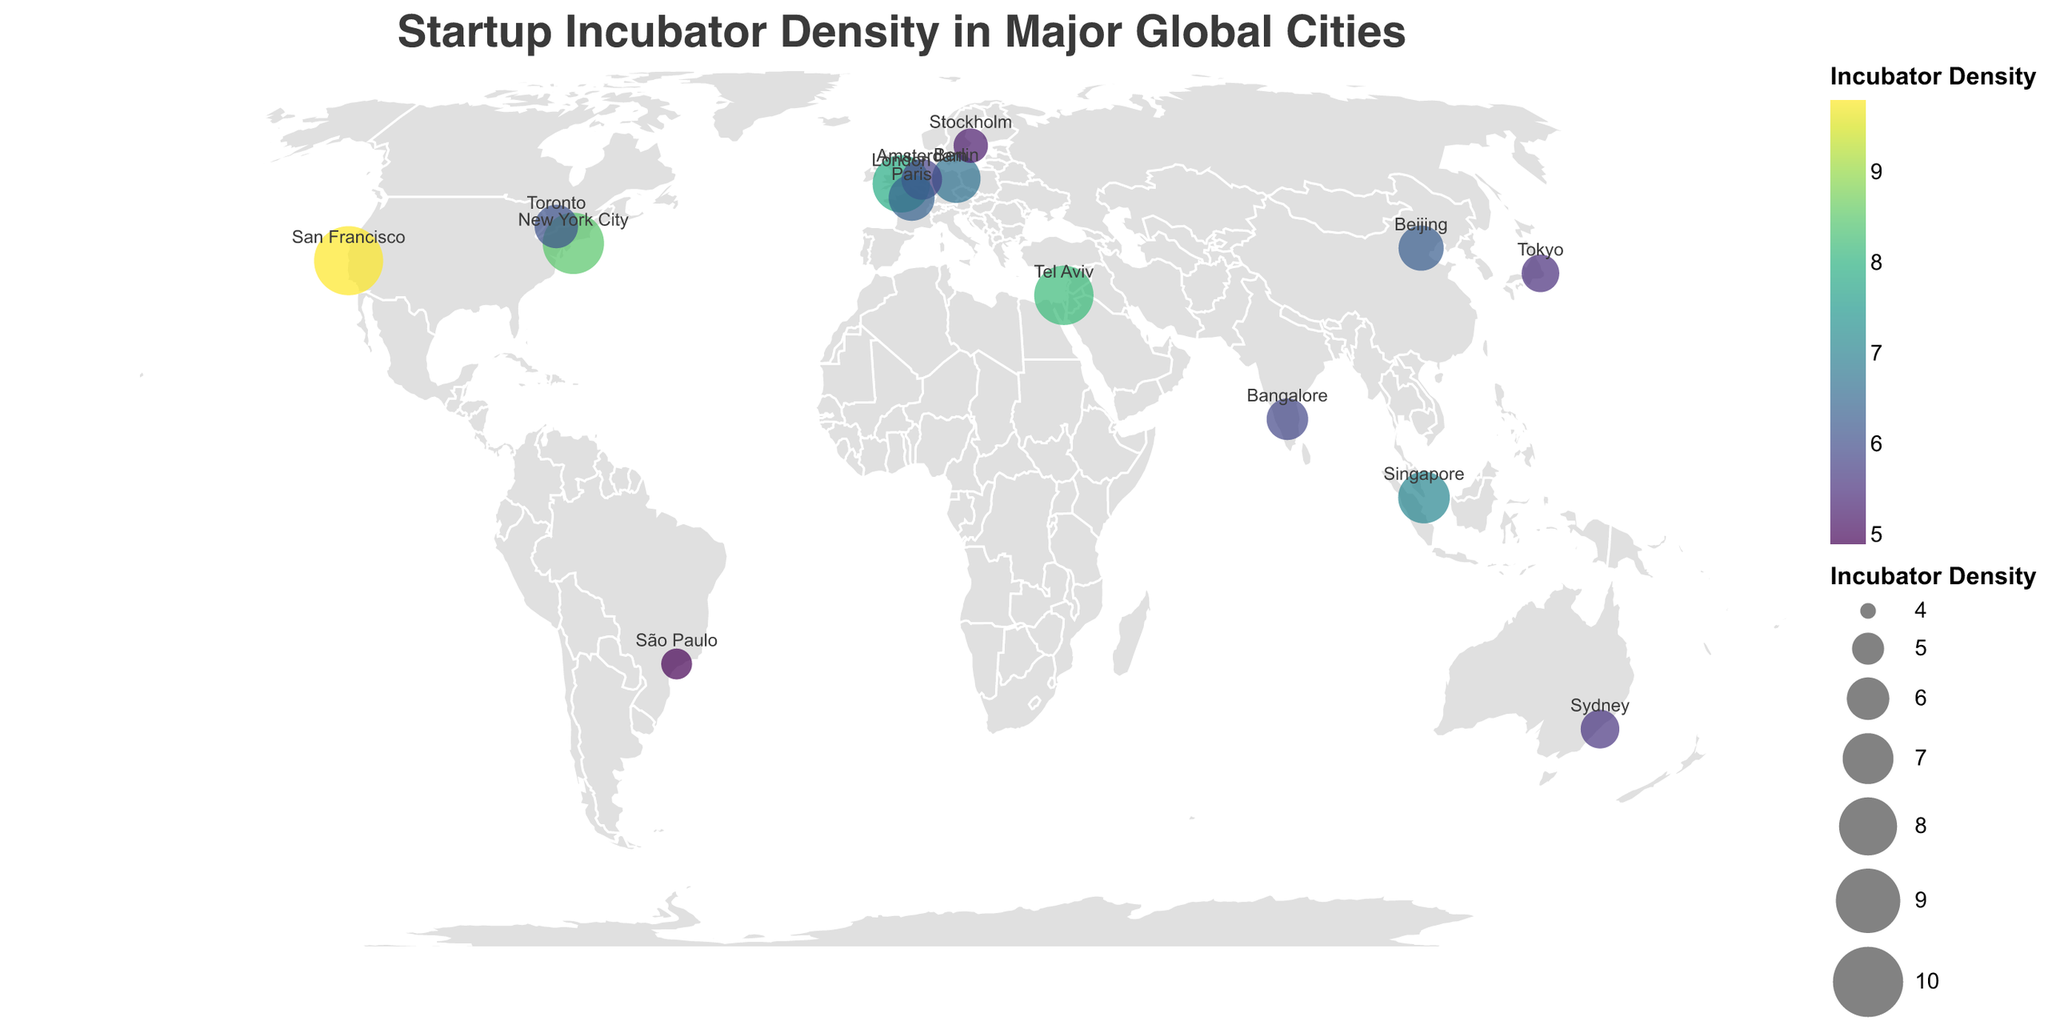What is the city with the highest incubator density on the map? By looking at the size and color of the circles, the largest and darkest one is over San Francisco, indicating it has the highest incubator density.
Answer: San Francisco Which city has a higher incubator density: Tel Aviv or London? By comparing the size and color of the circles for Tel Aviv and London, Tel Aviv's circle is slightly larger and darker than London's.
Answer: Tel Aviv What is the average incubator density of the cities in the USA? The incubator densities for San Francisco and New York City are 9.8 and 8.5, respectively. To find the average: (9.8 + 8.5) / 2 = 9.15
Answer: 9.15 Which country has more cities listed with incubator densities: USA or Germany? By counting the number of cities listed on the map, the USA has two cities (San Francisco and New York City), while Germany has one city (Berlin).
Answer: USA What is the combined incubator density for European cities on the map? The European cities listed are London (7.9), Berlin (6.7), Amsterdam (5.8), Paris (6.4), and Stockholm (5.2). The combined density is 7.9 + 6.7 + 5.8 + 6.4 + 5.2 = 32.0
Answer: 32.0 Which city is the farthest south on the map? By looking at the latitude values, Sydney has the southernmost latitude at -33.8688.
Answer: Sydney What is the median incubator density among all listed cities? To find the median, we first list the densities in ascending order: 4.9, 5.2, 5.5, 5.6, 5.8, 5.9, 6.1, 6.3, 6.4, 6.7, 7.1, 7.9, 8.2, 8.5, 9.8. The middle value (8th value in a list of 15) is 6.4.
Answer: 6.4 How many incubator densities are higher than 7.0? By checking the density values, these cities have densities higher than 7.0: San Francisco (9.8), New York City (8.5), Tel Aviv (8.2), and London (7.9), which makes a total of 4 cities.
Answer: 4 What is the difference in incubator density between the city with the highest value and the city with the lowest value? The highest value is for San Francisco (9.8) and the lowest is for São Paulo (4.9). The difference is 9.8 - 4.9 = 4.9.
Answer: 4.9 